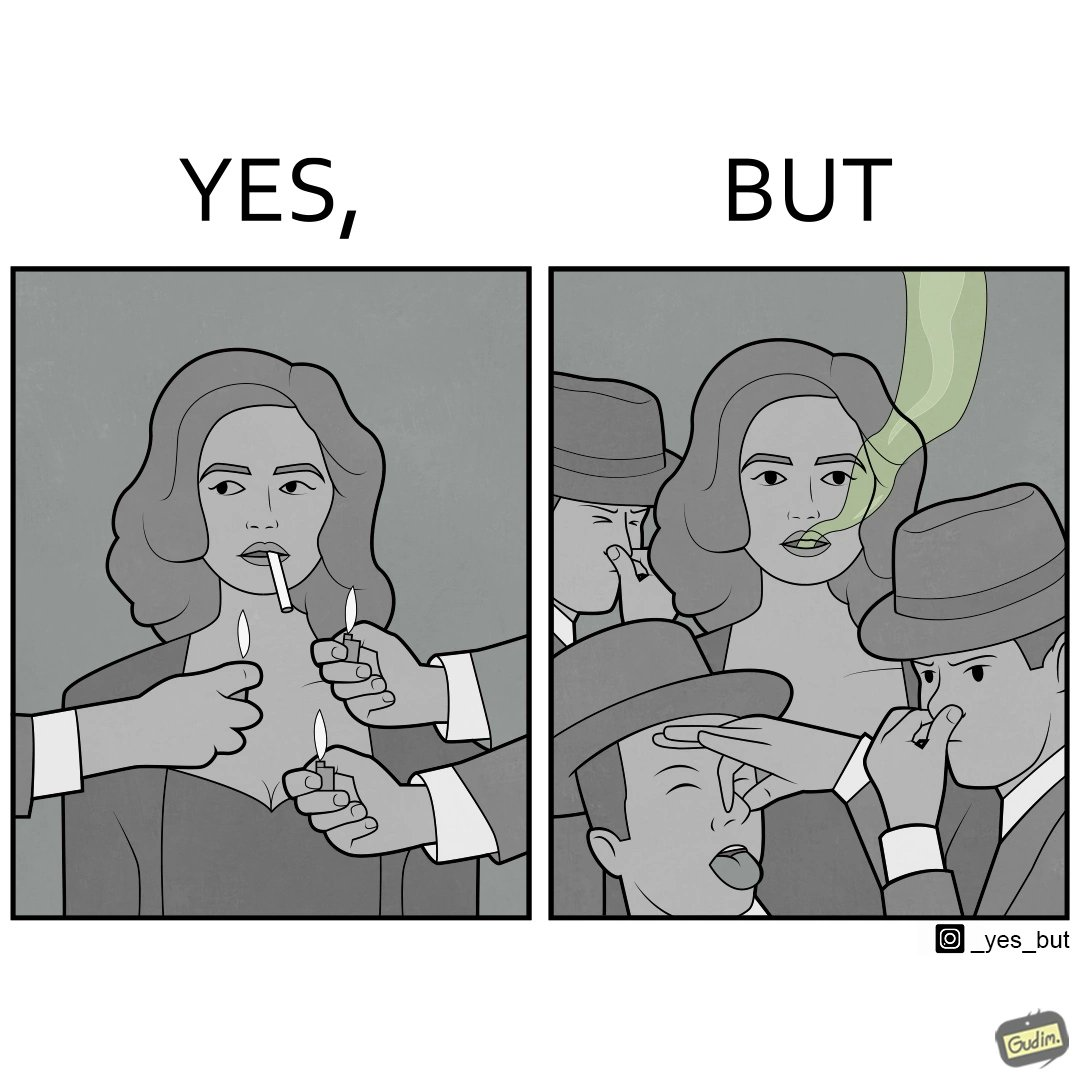Describe what you see in the left and right parts of this image. In the left part of the image: people holding lighters in front of a woman holding an unburnt cigarette in her mouth. In the right part of the image: people holding their noses on account of what appears to be bad smell coming out of a woman's mouth. 